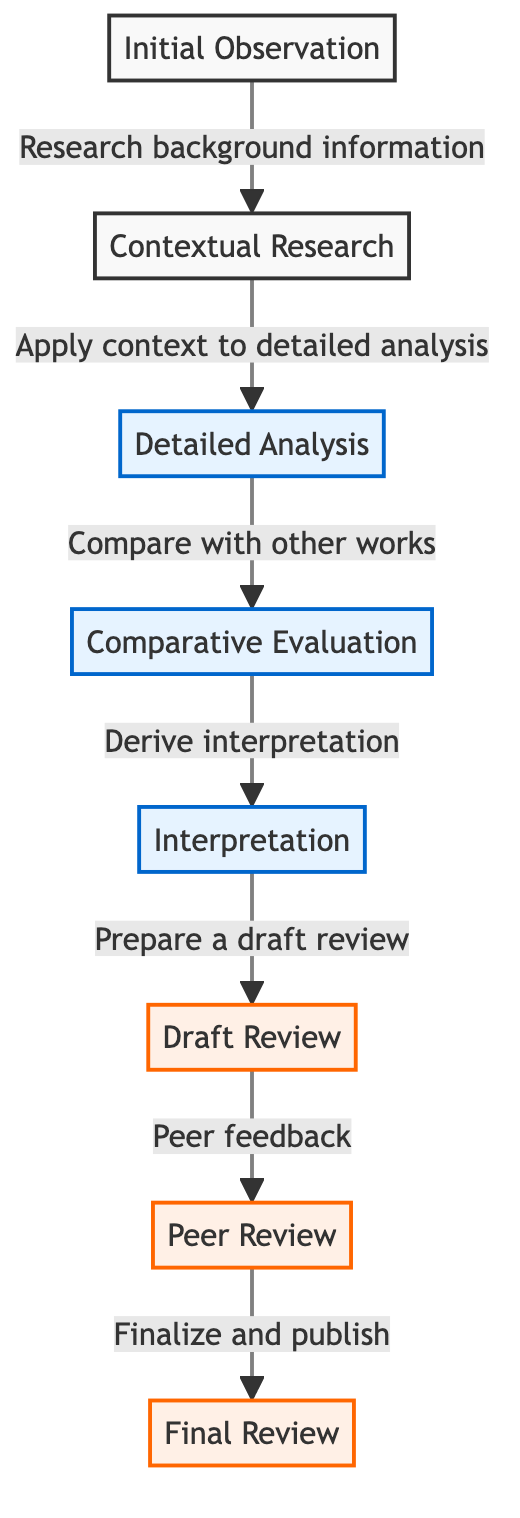What is the first step in the critique process? The first step in the critique process, as indicated by the first node in the diagram, is "Initial Observation."
Answer: Initial Observation How many nodes are in the critique process? By counting each unique process step in the diagram, we can see there are eight nodes representing different stages in the critique process.
Answer: 8 What step follows "Comparative Evaluation"? The diagram shows that "Interpretation" directly follows "Comparative Evaluation," indicating that the next phase involves deriving interpretation from earlier evaluations.
Answer: Interpretation What is the last step before "Final Review"? According to the flowchart, the step immediately preceding "Final Review" is "Peer Review." This indicates that peer feedback is an integral stage right before finalization and publication.
Answer: Peer Review Which node involves peer feedback? The node labeled "Peer Review" explicitly mentions peer feedback as a key activity occurring at that step in the critique process, indicating collaboration before finalizing the review.
Answer: Peer Review Which steps are classified as review processes? Observing the diagram, the steps labeled as review processes are "Draft Review," "Peer Review," and "Final Review," indicating that these stages concentrate on refining and finalizing the critique.
Answer: Draft Review, Peer Review, Final Review What action is taken after "Detailed Analysis"? The diagram indicates that the action taken after "Detailed Analysis" is to "Compare with other works," which marks a transition from analyzing details to contextualizing findings with other artworks.
Answer: Compare with other works How does "Contextual Research" contribute to the critique process? "Contextual Research" acts as a foundational step that feeds into "Detailed Analysis," ensuring that the critique has a well-informed basis before analyzing the artwork in detail.
Answer: Apply context to detailed analysis 